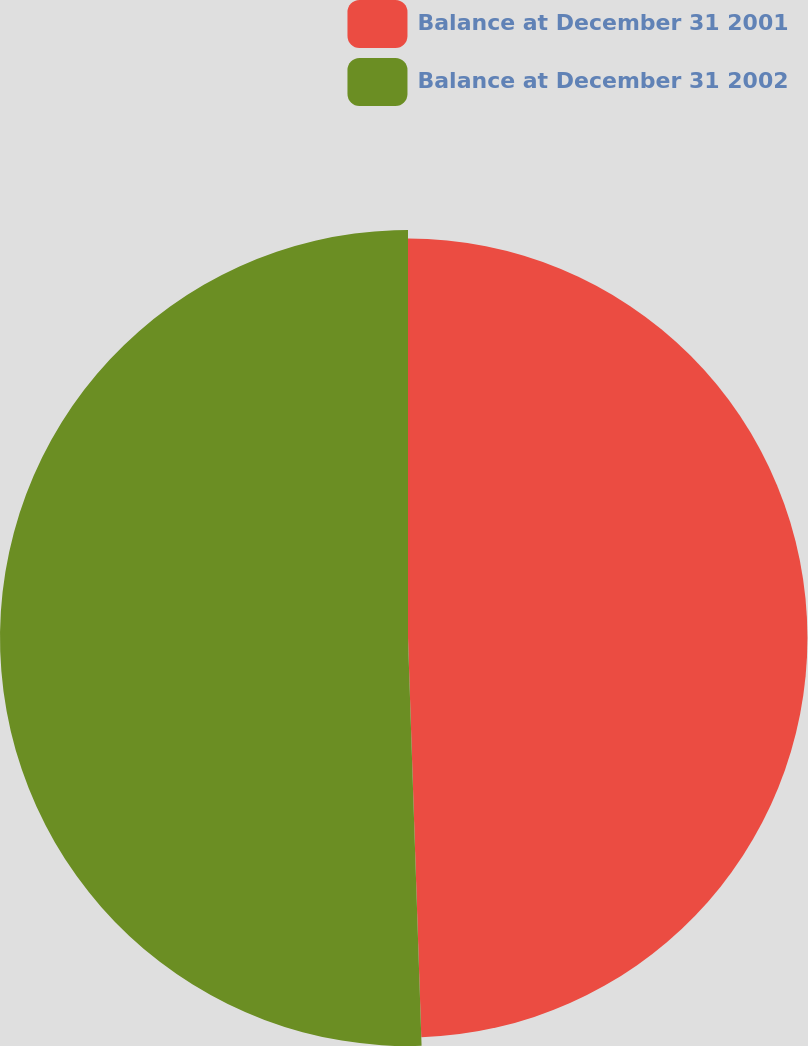Convert chart to OTSL. <chart><loc_0><loc_0><loc_500><loc_500><pie_chart><fcel>Balance at December 31 2001<fcel>Balance at December 31 2002<nl><fcel>49.47%<fcel>50.53%<nl></chart> 